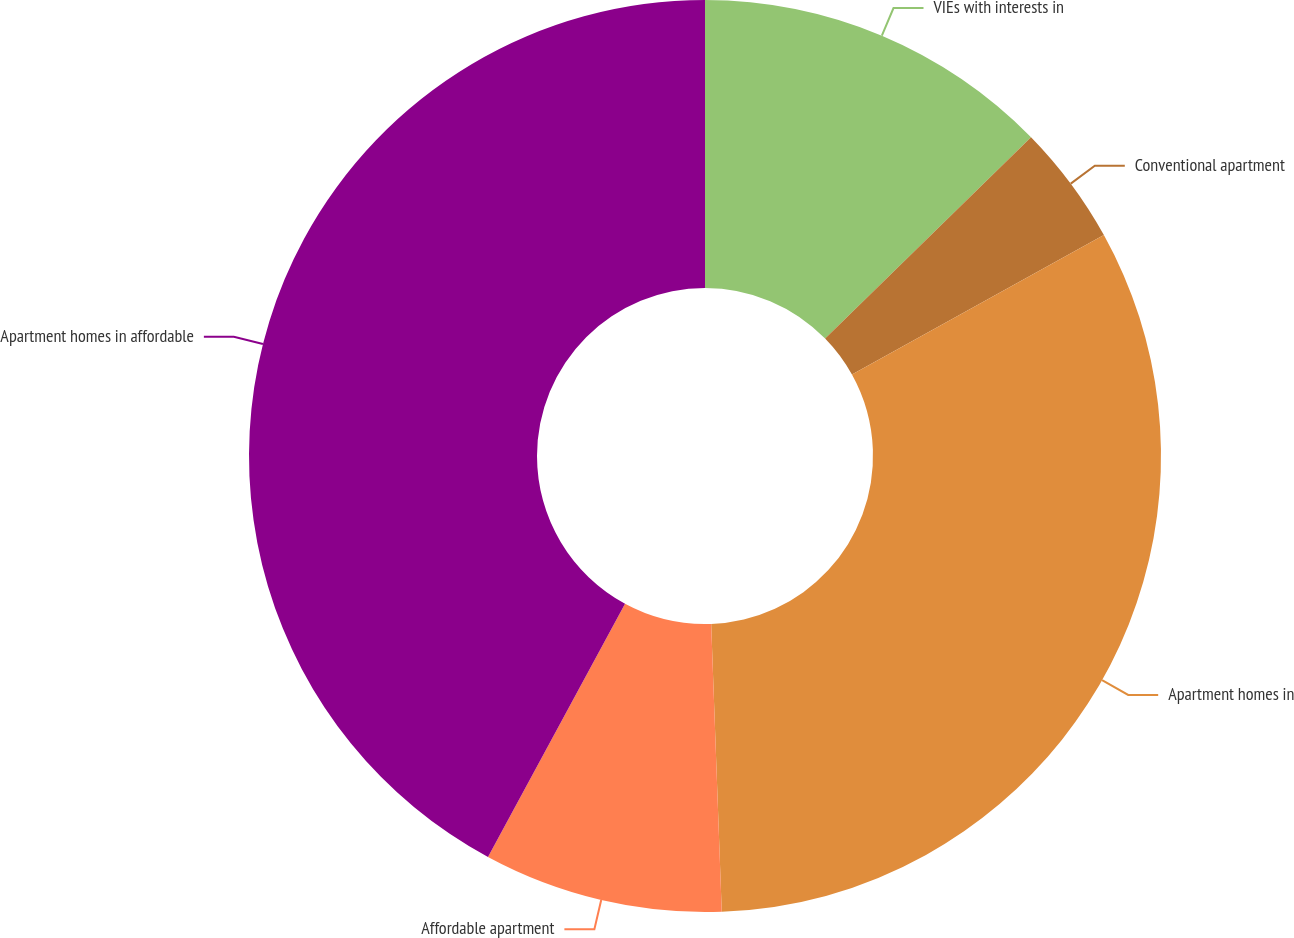<chart> <loc_0><loc_0><loc_500><loc_500><pie_chart><fcel>VIEs with interests in<fcel>Conventional apartment<fcel>Apartment homes in<fcel>Affordable apartment<fcel>Apartment homes in affordable<nl><fcel>12.68%<fcel>4.27%<fcel>32.47%<fcel>8.48%<fcel>42.11%<nl></chart> 